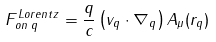Convert formula to latex. <formula><loc_0><loc_0><loc_500><loc_500>F _ { o n \, q } ^ { L o r e n t z } = \frac { q } { c } \left ( v _ { q } \cdot \nabla _ { q } \right ) A _ { \mu } ( r _ { q } )</formula> 